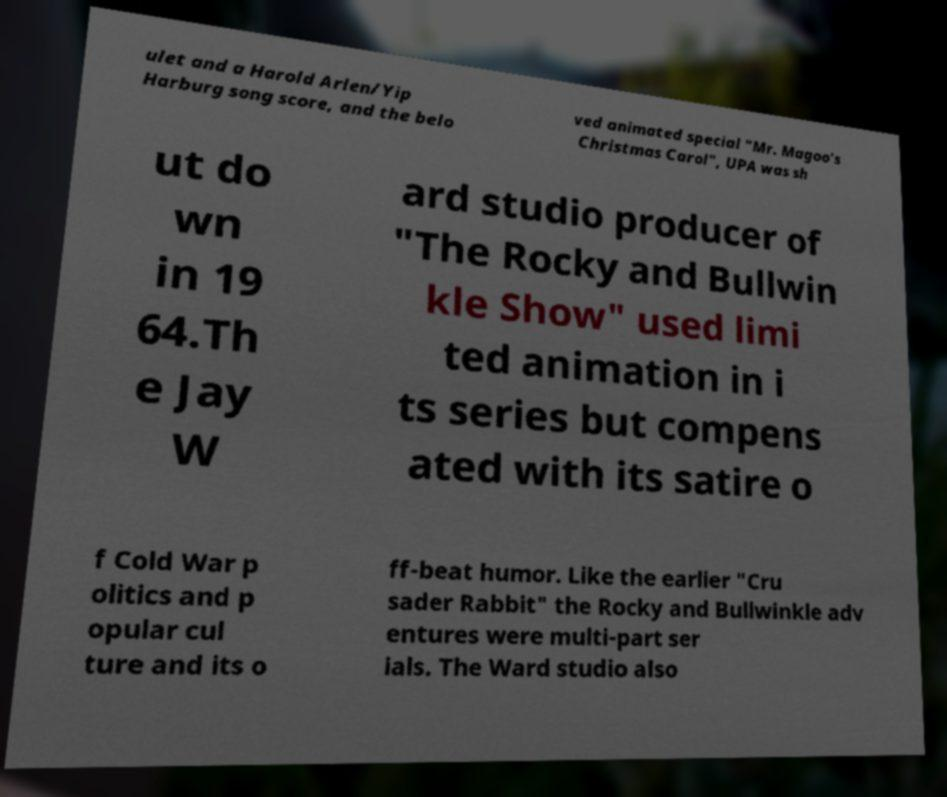Can you read and provide the text displayed in the image?This photo seems to have some interesting text. Can you extract and type it out for me? ulet and a Harold Arlen/Yip Harburg song score, and the belo ved animated special "Mr. Magoo's Christmas Carol", UPA was sh ut do wn in 19 64.Th e Jay W ard studio producer of "The Rocky and Bullwin kle Show" used limi ted animation in i ts series but compens ated with its satire o f Cold War p olitics and p opular cul ture and its o ff-beat humor. Like the earlier "Cru sader Rabbit" the Rocky and Bullwinkle adv entures were multi-part ser ials. The Ward studio also 